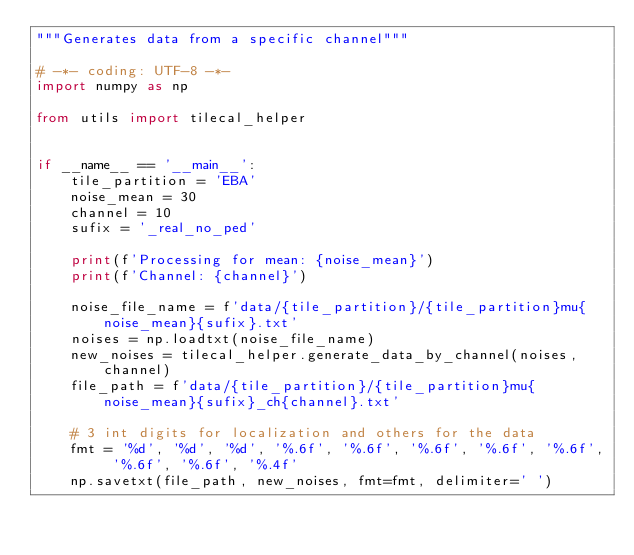Convert code to text. <code><loc_0><loc_0><loc_500><loc_500><_Python_>"""Generates data from a specific channel"""

# -*- coding: UTF-8 -*-
import numpy as np

from utils import tilecal_helper


if __name__ == '__main__':
    tile_partition = 'EBA'
    noise_mean = 30
    channel = 10
    sufix = '_real_no_ped'

    print(f'Processing for mean: {noise_mean}')
    print(f'Channel: {channel}')

    noise_file_name = f'data/{tile_partition}/{tile_partition}mu{noise_mean}{sufix}.txt'
    noises = np.loadtxt(noise_file_name)
    new_noises = tilecal_helper.generate_data_by_channel(noises, channel)
    file_path = f'data/{tile_partition}/{tile_partition}mu{noise_mean}{sufix}_ch{channel}.txt'

    # 3 int digits for localization and others for the data
    fmt = '%d', '%d', '%d', '%.6f', '%.6f', '%.6f', '%.6f', '%.6f', '%.6f', '%.6f', '%.4f'
    np.savetxt(file_path, new_noises, fmt=fmt, delimiter=' ')
</code> 